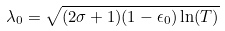<formula> <loc_0><loc_0><loc_500><loc_500>\lambda _ { 0 } = \sqrt { ( 2 \sigma + 1 ) ( 1 - \epsilon _ { 0 } ) \ln ( T ) }</formula> 